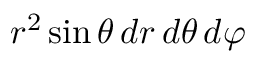<formula> <loc_0><loc_0><loc_500><loc_500>r ^ { 2 } \sin \theta \, d r \, d \theta \, d \varphi</formula> 